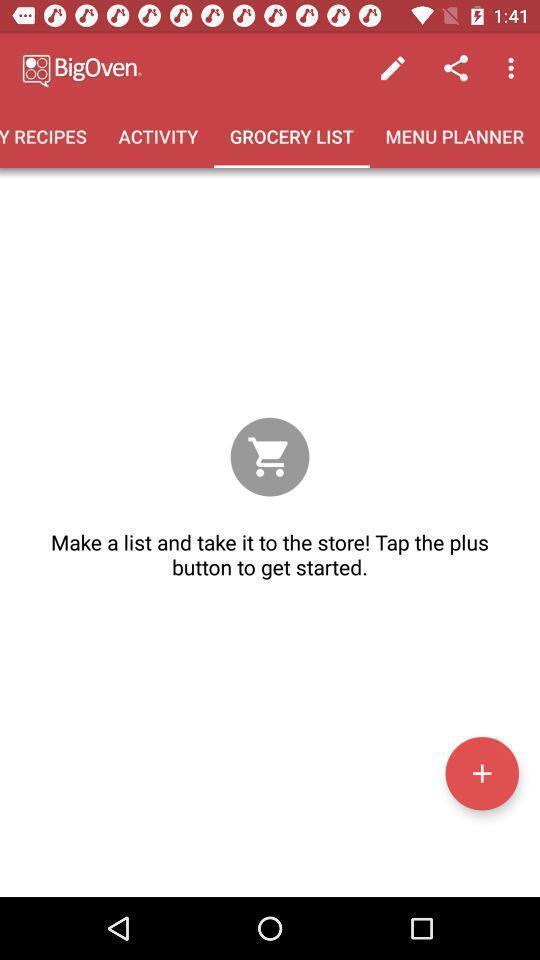Summarize the main components in this picture. Page displaying add icon. 